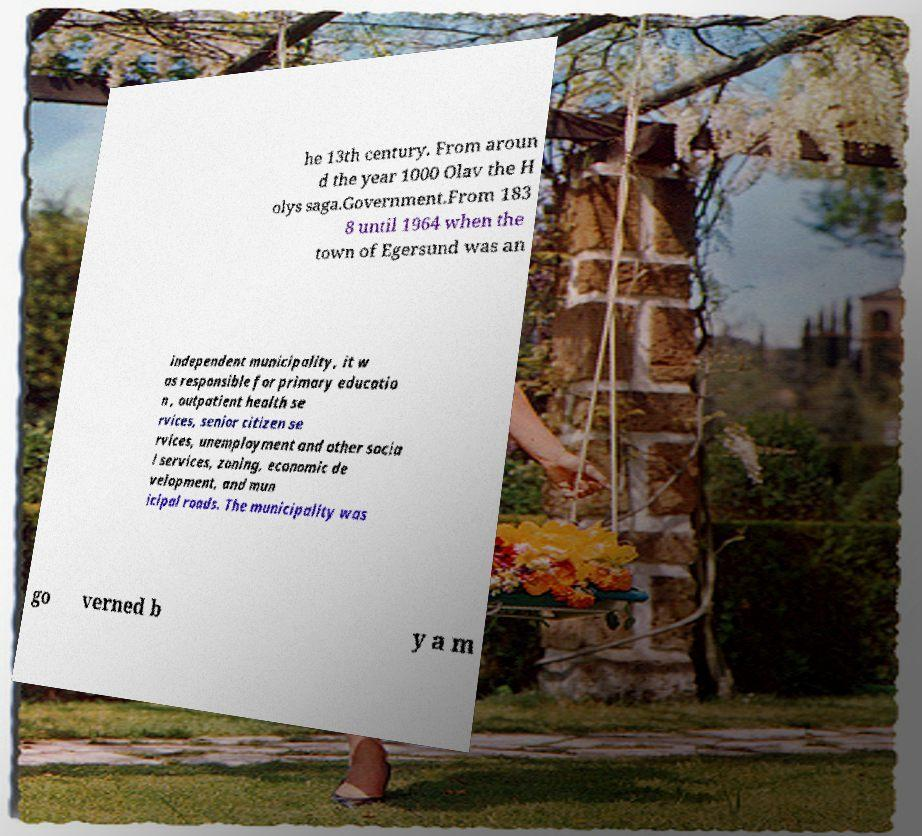Can you read and provide the text displayed in the image?This photo seems to have some interesting text. Can you extract and type it out for me? he 13th century. From aroun d the year 1000 Olav the H olys saga.Government.From 183 8 until 1964 when the town of Egersund was an independent municipality, it w as responsible for primary educatio n , outpatient health se rvices, senior citizen se rvices, unemployment and other socia l services, zoning, economic de velopment, and mun icipal roads. The municipality was go verned b y a m 